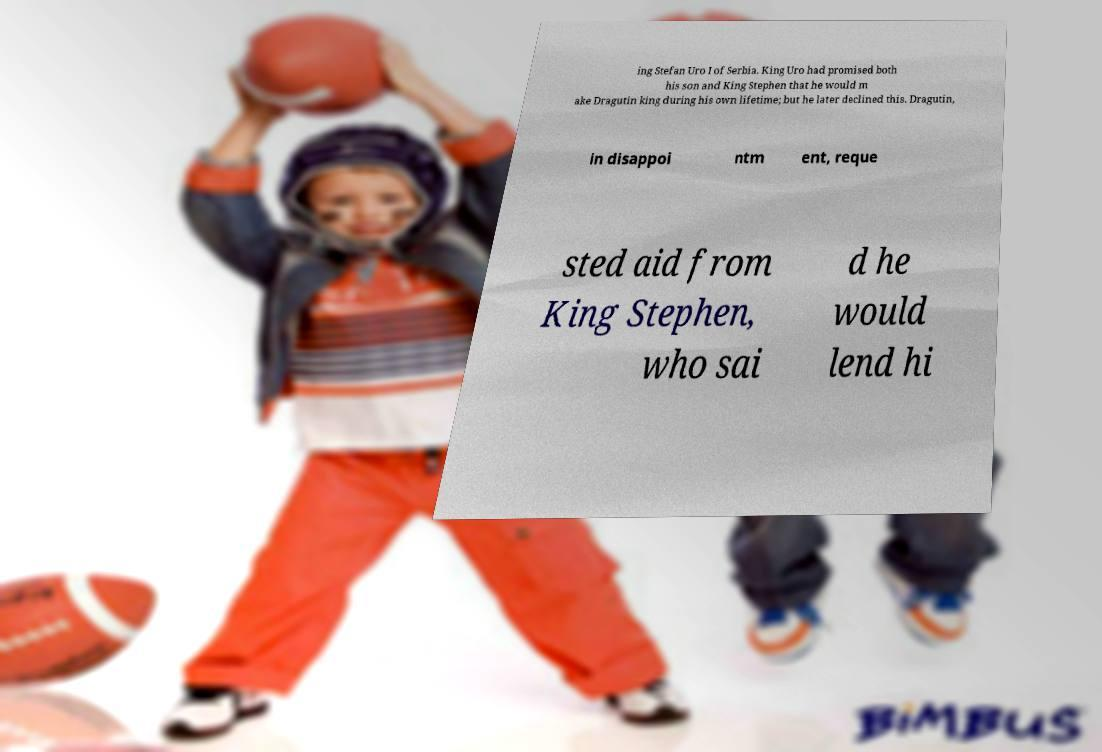Can you read and provide the text displayed in the image?This photo seems to have some interesting text. Can you extract and type it out for me? ing Stefan Uro I of Serbia. King Uro had promised both his son and King Stephen that he would m ake Dragutin king during his own lifetime; but he later declined this. Dragutin, in disappoi ntm ent, reque sted aid from King Stephen, who sai d he would lend hi 